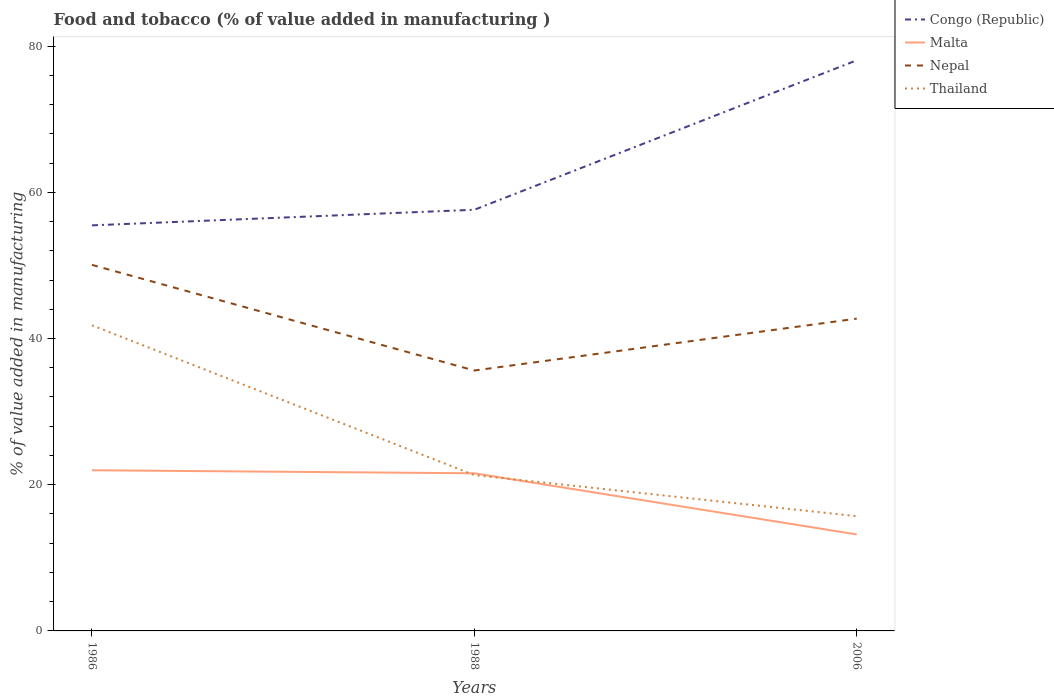Across all years, what is the maximum value added in manufacturing food and tobacco in Congo (Republic)?
Keep it short and to the point. 55.48. What is the total value added in manufacturing food and tobacco in Thailand in the graph?
Make the answer very short. 20.49. What is the difference between the highest and the second highest value added in manufacturing food and tobacco in Nepal?
Your answer should be compact. 14.45. Are the values on the major ticks of Y-axis written in scientific E-notation?
Keep it short and to the point. No. Does the graph contain any zero values?
Offer a terse response. No. Does the graph contain grids?
Offer a very short reply. No. Where does the legend appear in the graph?
Your answer should be very brief. Top right. How many legend labels are there?
Give a very brief answer. 4. What is the title of the graph?
Your answer should be compact. Food and tobacco (% of value added in manufacturing ). What is the label or title of the X-axis?
Your answer should be very brief. Years. What is the label or title of the Y-axis?
Keep it short and to the point. % of value added in manufacturing. What is the % of value added in manufacturing of Congo (Republic) in 1986?
Make the answer very short. 55.48. What is the % of value added in manufacturing in Malta in 1986?
Your answer should be very brief. 21.98. What is the % of value added in manufacturing of Nepal in 1986?
Ensure brevity in your answer.  50.08. What is the % of value added in manufacturing in Thailand in 1986?
Make the answer very short. 41.81. What is the % of value added in manufacturing of Congo (Republic) in 1988?
Provide a succinct answer. 57.61. What is the % of value added in manufacturing in Malta in 1988?
Your answer should be compact. 21.56. What is the % of value added in manufacturing in Nepal in 1988?
Give a very brief answer. 35.62. What is the % of value added in manufacturing in Thailand in 1988?
Offer a very short reply. 21.31. What is the % of value added in manufacturing in Congo (Republic) in 2006?
Provide a succinct answer. 78.06. What is the % of value added in manufacturing of Malta in 2006?
Provide a succinct answer. 13.2. What is the % of value added in manufacturing of Nepal in 2006?
Offer a terse response. 42.72. What is the % of value added in manufacturing in Thailand in 2006?
Offer a very short reply. 15.7. Across all years, what is the maximum % of value added in manufacturing in Congo (Republic)?
Keep it short and to the point. 78.06. Across all years, what is the maximum % of value added in manufacturing in Malta?
Your answer should be compact. 21.98. Across all years, what is the maximum % of value added in manufacturing in Nepal?
Ensure brevity in your answer.  50.08. Across all years, what is the maximum % of value added in manufacturing in Thailand?
Give a very brief answer. 41.81. Across all years, what is the minimum % of value added in manufacturing of Congo (Republic)?
Your answer should be compact. 55.48. Across all years, what is the minimum % of value added in manufacturing of Malta?
Provide a succinct answer. 13.2. Across all years, what is the minimum % of value added in manufacturing in Nepal?
Give a very brief answer. 35.62. Across all years, what is the minimum % of value added in manufacturing of Thailand?
Provide a succinct answer. 15.7. What is the total % of value added in manufacturing in Congo (Republic) in the graph?
Offer a very short reply. 191.16. What is the total % of value added in manufacturing in Malta in the graph?
Provide a short and direct response. 56.75. What is the total % of value added in manufacturing in Nepal in the graph?
Your answer should be very brief. 128.42. What is the total % of value added in manufacturing in Thailand in the graph?
Offer a terse response. 78.82. What is the difference between the % of value added in manufacturing of Congo (Republic) in 1986 and that in 1988?
Offer a terse response. -2.13. What is the difference between the % of value added in manufacturing of Malta in 1986 and that in 1988?
Provide a succinct answer. 0.42. What is the difference between the % of value added in manufacturing in Nepal in 1986 and that in 1988?
Provide a short and direct response. 14.45. What is the difference between the % of value added in manufacturing in Thailand in 1986 and that in 1988?
Your response must be concise. 20.49. What is the difference between the % of value added in manufacturing in Congo (Republic) in 1986 and that in 2006?
Offer a terse response. -22.58. What is the difference between the % of value added in manufacturing of Malta in 1986 and that in 2006?
Keep it short and to the point. 8.78. What is the difference between the % of value added in manufacturing in Nepal in 1986 and that in 2006?
Ensure brevity in your answer.  7.36. What is the difference between the % of value added in manufacturing in Thailand in 1986 and that in 2006?
Keep it short and to the point. 26.11. What is the difference between the % of value added in manufacturing of Congo (Republic) in 1988 and that in 2006?
Your answer should be very brief. -20.45. What is the difference between the % of value added in manufacturing in Malta in 1988 and that in 2006?
Give a very brief answer. 8.36. What is the difference between the % of value added in manufacturing of Nepal in 1988 and that in 2006?
Offer a terse response. -7.1. What is the difference between the % of value added in manufacturing of Thailand in 1988 and that in 2006?
Keep it short and to the point. 5.62. What is the difference between the % of value added in manufacturing in Congo (Republic) in 1986 and the % of value added in manufacturing in Malta in 1988?
Your response must be concise. 33.92. What is the difference between the % of value added in manufacturing in Congo (Republic) in 1986 and the % of value added in manufacturing in Nepal in 1988?
Provide a short and direct response. 19.86. What is the difference between the % of value added in manufacturing in Congo (Republic) in 1986 and the % of value added in manufacturing in Thailand in 1988?
Offer a very short reply. 34.17. What is the difference between the % of value added in manufacturing of Malta in 1986 and the % of value added in manufacturing of Nepal in 1988?
Give a very brief answer. -13.64. What is the difference between the % of value added in manufacturing in Malta in 1986 and the % of value added in manufacturing in Thailand in 1988?
Give a very brief answer. 0.67. What is the difference between the % of value added in manufacturing of Nepal in 1986 and the % of value added in manufacturing of Thailand in 1988?
Offer a terse response. 28.76. What is the difference between the % of value added in manufacturing in Congo (Republic) in 1986 and the % of value added in manufacturing in Malta in 2006?
Offer a terse response. 42.28. What is the difference between the % of value added in manufacturing in Congo (Republic) in 1986 and the % of value added in manufacturing in Nepal in 2006?
Your response must be concise. 12.76. What is the difference between the % of value added in manufacturing of Congo (Republic) in 1986 and the % of value added in manufacturing of Thailand in 2006?
Provide a succinct answer. 39.79. What is the difference between the % of value added in manufacturing in Malta in 1986 and the % of value added in manufacturing in Nepal in 2006?
Ensure brevity in your answer.  -20.74. What is the difference between the % of value added in manufacturing in Malta in 1986 and the % of value added in manufacturing in Thailand in 2006?
Offer a terse response. 6.28. What is the difference between the % of value added in manufacturing in Nepal in 1986 and the % of value added in manufacturing in Thailand in 2006?
Your response must be concise. 34.38. What is the difference between the % of value added in manufacturing of Congo (Republic) in 1988 and the % of value added in manufacturing of Malta in 2006?
Offer a terse response. 44.41. What is the difference between the % of value added in manufacturing in Congo (Republic) in 1988 and the % of value added in manufacturing in Nepal in 2006?
Make the answer very short. 14.89. What is the difference between the % of value added in manufacturing in Congo (Republic) in 1988 and the % of value added in manufacturing in Thailand in 2006?
Ensure brevity in your answer.  41.92. What is the difference between the % of value added in manufacturing of Malta in 1988 and the % of value added in manufacturing of Nepal in 2006?
Ensure brevity in your answer.  -21.16. What is the difference between the % of value added in manufacturing of Malta in 1988 and the % of value added in manufacturing of Thailand in 2006?
Your response must be concise. 5.87. What is the difference between the % of value added in manufacturing in Nepal in 1988 and the % of value added in manufacturing in Thailand in 2006?
Your answer should be very brief. 19.93. What is the average % of value added in manufacturing in Congo (Republic) per year?
Offer a very short reply. 63.72. What is the average % of value added in manufacturing of Malta per year?
Your answer should be very brief. 18.92. What is the average % of value added in manufacturing of Nepal per year?
Provide a short and direct response. 42.81. What is the average % of value added in manufacturing of Thailand per year?
Provide a succinct answer. 26.27. In the year 1986, what is the difference between the % of value added in manufacturing in Congo (Republic) and % of value added in manufacturing in Malta?
Your answer should be very brief. 33.5. In the year 1986, what is the difference between the % of value added in manufacturing in Congo (Republic) and % of value added in manufacturing in Nepal?
Provide a succinct answer. 5.4. In the year 1986, what is the difference between the % of value added in manufacturing of Congo (Republic) and % of value added in manufacturing of Thailand?
Provide a succinct answer. 13.67. In the year 1986, what is the difference between the % of value added in manufacturing in Malta and % of value added in manufacturing in Nepal?
Ensure brevity in your answer.  -28.1. In the year 1986, what is the difference between the % of value added in manufacturing in Malta and % of value added in manufacturing in Thailand?
Ensure brevity in your answer.  -19.83. In the year 1986, what is the difference between the % of value added in manufacturing in Nepal and % of value added in manufacturing in Thailand?
Your answer should be compact. 8.27. In the year 1988, what is the difference between the % of value added in manufacturing of Congo (Republic) and % of value added in manufacturing of Malta?
Your response must be concise. 36.05. In the year 1988, what is the difference between the % of value added in manufacturing of Congo (Republic) and % of value added in manufacturing of Nepal?
Your answer should be very brief. 21.99. In the year 1988, what is the difference between the % of value added in manufacturing of Congo (Republic) and % of value added in manufacturing of Thailand?
Your answer should be compact. 36.3. In the year 1988, what is the difference between the % of value added in manufacturing of Malta and % of value added in manufacturing of Nepal?
Your answer should be compact. -14.06. In the year 1988, what is the difference between the % of value added in manufacturing in Malta and % of value added in manufacturing in Thailand?
Your response must be concise. 0.25. In the year 1988, what is the difference between the % of value added in manufacturing in Nepal and % of value added in manufacturing in Thailand?
Give a very brief answer. 14.31. In the year 2006, what is the difference between the % of value added in manufacturing in Congo (Republic) and % of value added in manufacturing in Malta?
Your answer should be very brief. 64.86. In the year 2006, what is the difference between the % of value added in manufacturing in Congo (Republic) and % of value added in manufacturing in Nepal?
Your answer should be compact. 35.34. In the year 2006, what is the difference between the % of value added in manufacturing in Congo (Republic) and % of value added in manufacturing in Thailand?
Your answer should be compact. 62.37. In the year 2006, what is the difference between the % of value added in manufacturing of Malta and % of value added in manufacturing of Nepal?
Ensure brevity in your answer.  -29.52. In the year 2006, what is the difference between the % of value added in manufacturing in Malta and % of value added in manufacturing in Thailand?
Offer a very short reply. -2.49. In the year 2006, what is the difference between the % of value added in manufacturing of Nepal and % of value added in manufacturing of Thailand?
Give a very brief answer. 27.02. What is the ratio of the % of value added in manufacturing of Congo (Republic) in 1986 to that in 1988?
Ensure brevity in your answer.  0.96. What is the ratio of the % of value added in manufacturing of Malta in 1986 to that in 1988?
Make the answer very short. 1.02. What is the ratio of the % of value added in manufacturing in Nepal in 1986 to that in 1988?
Your answer should be compact. 1.41. What is the ratio of the % of value added in manufacturing of Thailand in 1986 to that in 1988?
Keep it short and to the point. 1.96. What is the ratio of the % of value added in manufacturing in Congo (Republic) in 1986 to that in 2006?
Offer a very short reply. 0.71. What is the ratio of the % of value added in manufacturing in Malta in 1986 to that in 2006?
Provide a succinct answer. 1.67. What is the ratio of the % of value added in manufacturing of Nepal in 1986 to that in 2006?
Your answer should be very brief. 1.17. What is the ratio of the % of value added in manufacturing in Thailand in 1986 to that in 2006?
Provide a succinct answer. 2.66. What is the ratio of the % of value added in manufacturing of Congo (Republic) in 1988 to that in 2006?
Offer a terse response. 0.74. What is the ratio of the % of value added in manufacturing in Malta in 1988 to that in 2006?
Give a very brief answer. 1.63. What is the ratio of the % of value added in manufacturing in Nepal in 1988 to that in 2006?
Keep it short and to the point. 0.83. What is the ratio of the % of value added in manufacturing in Thailand in 1988 to that in 2006?
Offer a terse response. 1.36. What is the difference between the highest and the second highest % of value added in manufacturing in Congo (Republic)?
Provide a succinct answer. 20.45. What is the difference between the highest and the second highest % of value added in manufacturing in Malta?
Keep it short and to the point. 0.42. What is the difference between the highest and the second highest % of value added in manufacturing in Nepal?
Provide a succinct answer. 7.36. What is the difference between the highest and the second highest % of value added in manufacturing of Thailand?
Make the answer very short. 20.49. What is the difference between the highest and the lowest % of value added in manufacturing of Congo (Republic)?
Your answer should be compact. 22.58. What is the difference between the highest and the lowest % of value added in manufacturing in Malta?
Your response must be concise. 8.78. What is the difference between the highest and the lowest % of value added in manufacturing in Nepal?
Give a very brief answer. 14.45. What is the difference between the highest and the lowest % of value added in manufacturing of Thailand?
Offer a terse response. 26.11. 